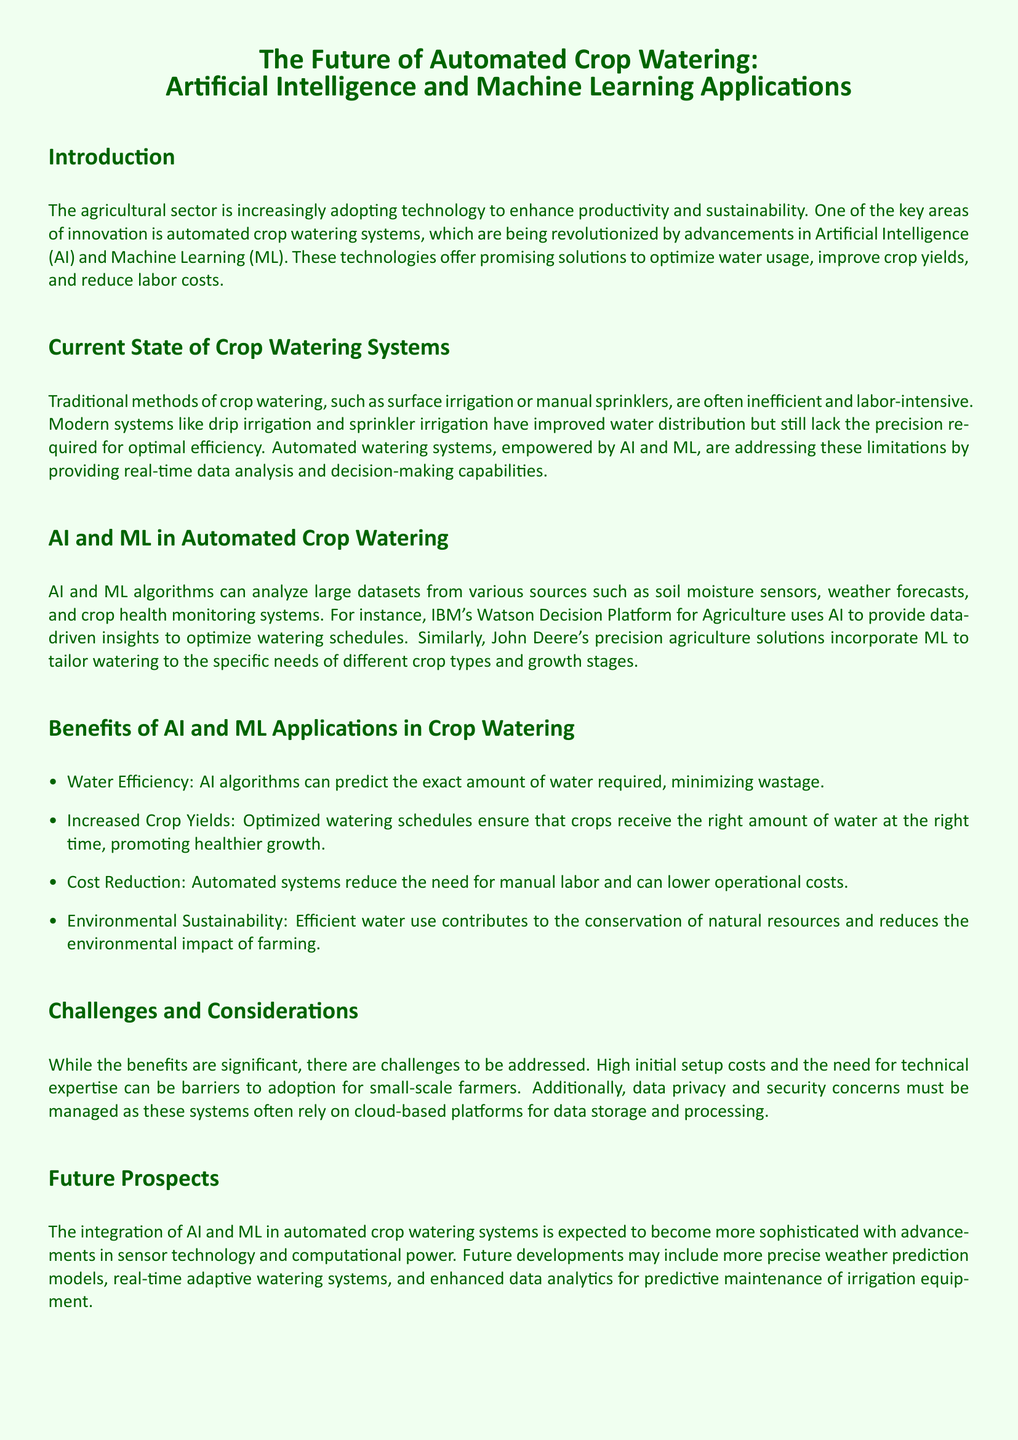What is the focus of the whitepaper? The whitepaper focuses on the impact of AI and ML on automated crop watering systems.
Answer: AI and ML applications in automated crop watering What technology does IBM's Watson utilize for agriculture? IBM's Watson uses AI to provide data-driven insights for optimizing watering schedules.
Answer: AI What are two traditional methods of crop watering mentioned? The document mentions surface irrigation and manual sprinklers as traditional methods of watering.
Answer: Surface irrigation and manual sprinklers What is a key benefit of AI in crop watering systems? AI algorithms can minimize water wastage by predicting the exact amount of water required.
Answer: Water efficiency What barrier to adoption is mentioned for small-scale farmers? The high initial setup costs are highlighted as a barrier for small-scale farmers adopting automated systems.
Answer: High initial setup costs How does automated watering benefit crop yields? Optimized watering schedules ensure that crops receive the right amount of water, promoting healthier growth.
Answer: Increased crop yields Which technology is expected to advance in the future for crop watering? The document mentions that sensor technology will become more sophisticated in the future.
Answer: Sensor technology What is one concern regarding data for automated systems? Data privacy and security concerns are raised as important considerations for automated watering systems.
Answer: Data privacy and security What do the references include in the document? The references include links related to IBM Watson, John Deere, and Blue River Technology.
Answer: IBM Watson Decision Platform for Agriculture, John Deere Precision Agriculture Solutions, Blue River Technology 